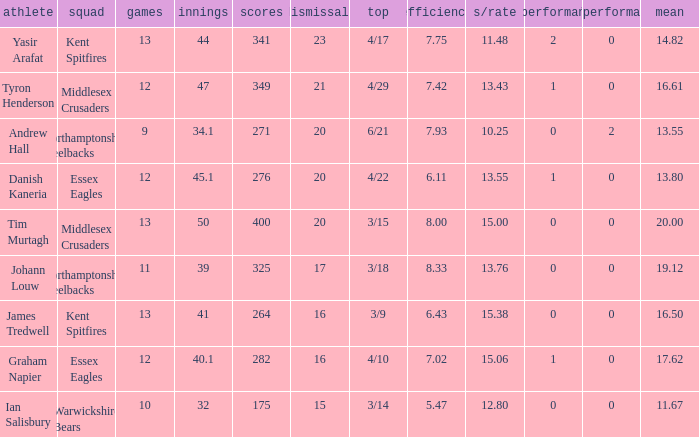Name the least matches for runs being 276 12.0. 